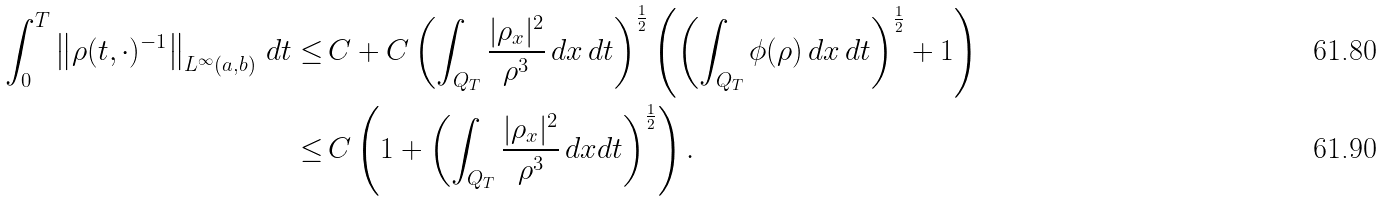<formula> <loc_0><loc_0><loc_500><loc_500>\int _ { 0 } ^ { T } \left \| \rho ( t , \cdot ) ^ { - 1 } \right \| _ { L ^ { \infty } ( a , b ) } \, d t \leq & \, C + C \left ( \int _ { Q _ { T } } \frac { | \rho _ { x } | ^ { 2 } } { \rho ^ { 3 } } \, d x \, d t \right ) ^ { \frac { 1 } { 2 } } \left ( \left ( \int _ { Q _ { T } } \phi ( \rho ) \, d x \, d t \right ) ^ { \frac { 1 } { 2 } } + 1 \right ) \\ \leq & \, C \left ( 1 + \left ( \int _ { Q _ { T } } \frac { | \rho _ { x } | ^ { 2 } } { \rho ^ { 3 } } \, d x d t \right ) ^ { \frac { 1 } { 2 } } \right ) .</formula> 